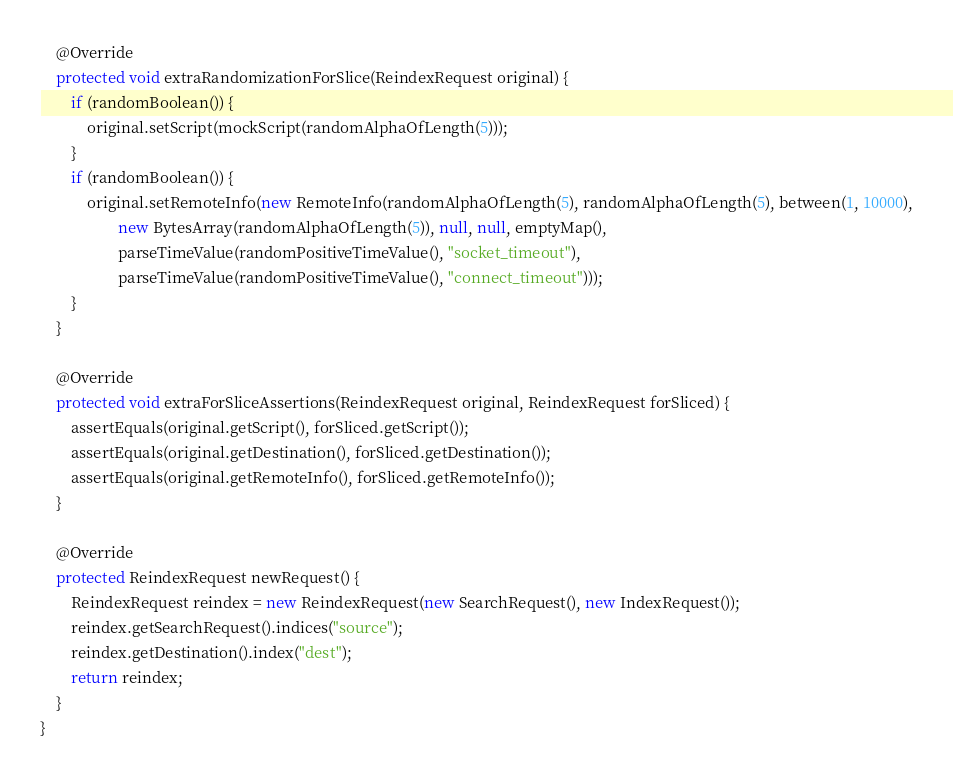<code> <loc_0><loc_0><loc_500><loc_500><_Java_>
    @Override
    protected void extraRandomizationForSlice(ReindexRequest original) {
        if (randomBoolean()) {
            original.setScript(mockScript(randomAlphaOfLength(5)));
        }
        if (randomBoolean()) {
            original.setRemoteInfo(new RemoteInfo(randomAlphaOfLength(5), randomAlphaOfLength(5), between(1, 10000),
                    new BytesArray(randomAlphaOfLength(5)), null, null, emptyMap(),
                    parseTimeValue(randomPositiveTimeValue(), "socket_timeout"),
                    parseTimeValue(randomPositiveTimeValue(), "connect_timeout")));
        }
    }

    @Override
    protected void extraForSliceAssertions(ReindexRequest original, ReindexRequest forSliced) {
        assertEquals(original.getScript(), forSliced.getScript());
        assertEquals(original.getDestination(), forSliced.getDestination());
        assertEquals(original.getRemoteInfo(), forSliced.getRemoteInfo());
    }

    @Override
    protected ReindexRequest newRequest() {
        ReindexRequest reindex = new ReindexRequest(new SearchRequest(), new IndexRequest());
        reindex.getSearchRequest().indices("source");
        reindex.getDestination().index("dest");
        return reindex;
    }
}
</code> 